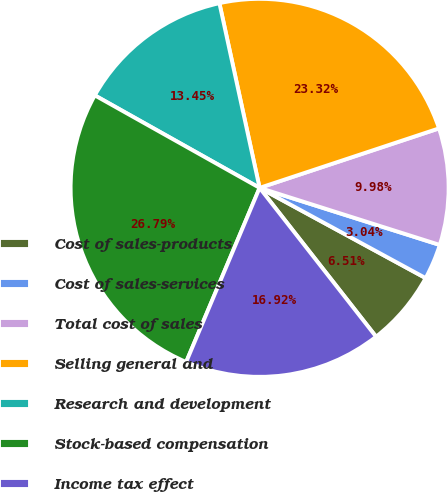Convert chart. <chart><loc_0><loc_0><loc_500><loc_500><pie_chart><fcel>Cost of sales-products<fcel>Cost of sales-services<fcel>Total cost of sales<fcel>Selling general and<fcel>Research and development<fcel>Stock-based compensation<fcel>Income tax effect<nl><fcel>6.51%<fcel>3.04%<fcel>9.98%<fcel>23.32%<fcel>13.45%<fcel>26.79%<fcel>16.92%<nl></chart> 